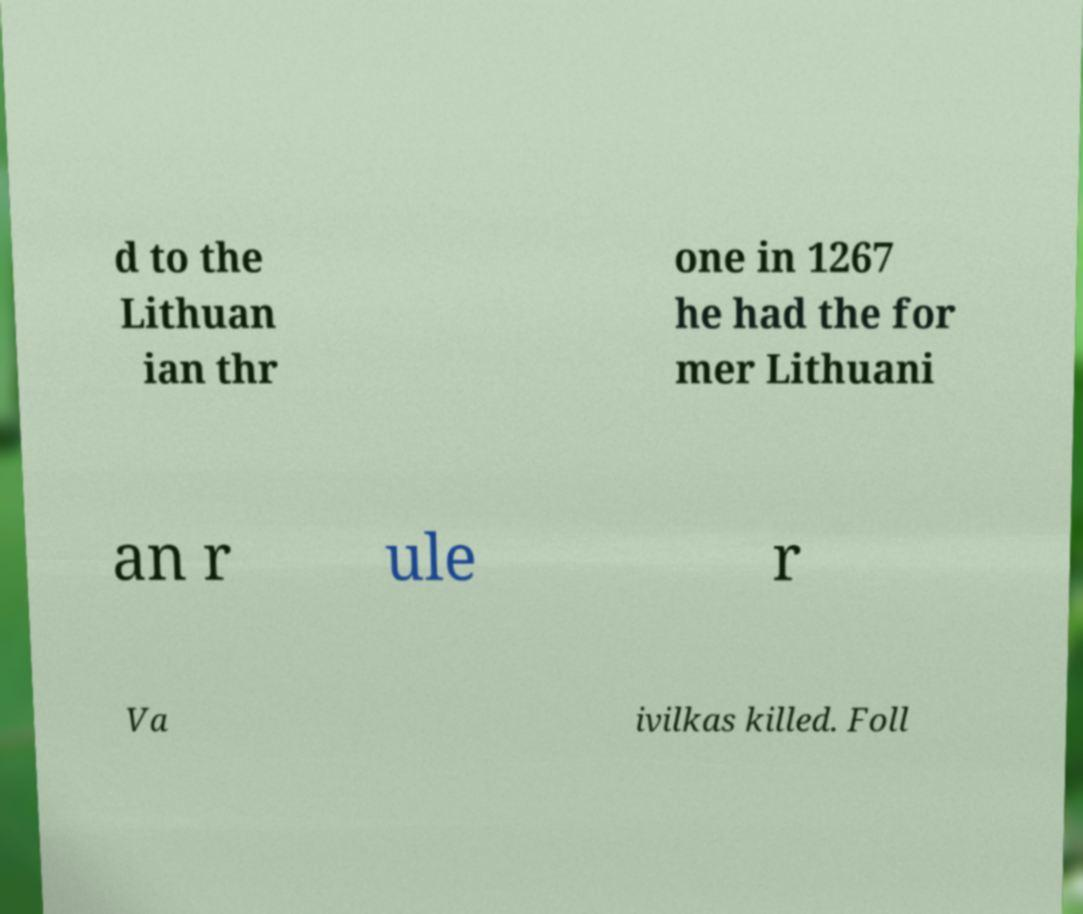Could you extract and type out the text from this image? d to the Lithuan ian thr one in 1267 he had the for mer Lithuani an r ule r Va ivilkas killed. Foll 